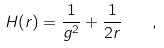<formula> <loc_0><loc_0><loc_500><loc_500>H ( r ) = \frac { 1 } { g ^ { 2 } } + \frac { 1 } { 2 r } \quad ,</formula> 